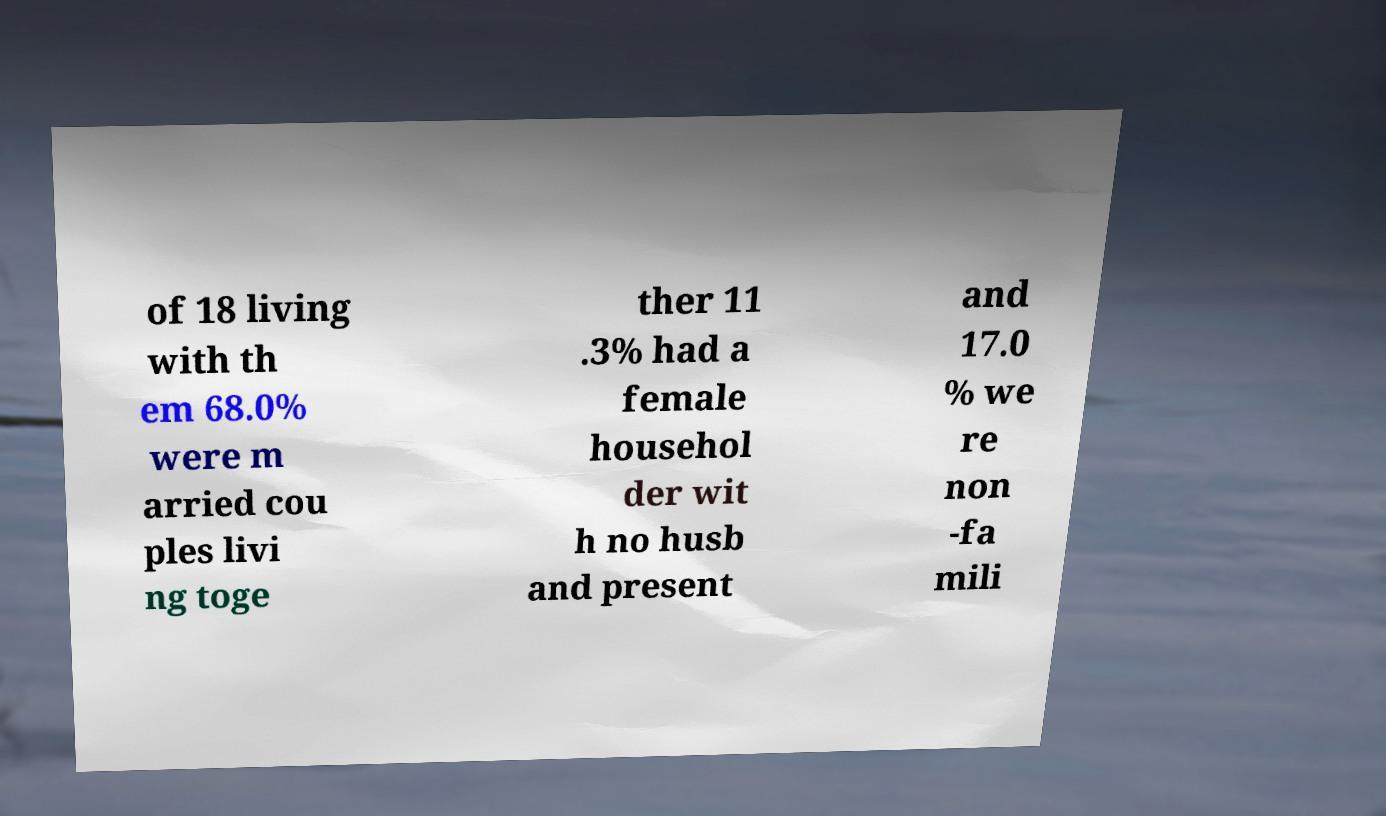For documentation purposes, I need the text within this image transcribed. Could you provide that? of 18 living with th em 68.0% were m arried cou ples livi ng toge ther 11 .3% had a female househol der wit h no husb and present and 17.0 % we re non -fa mili 